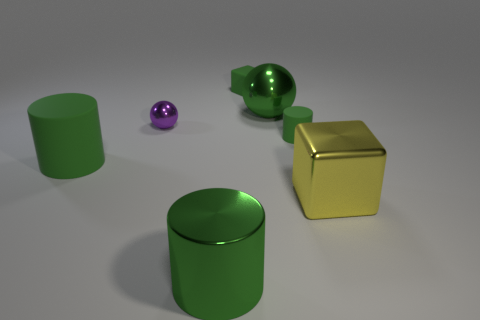Subtract all green cylinders. How many were subtracted if there are1green cylinders left? 2 Subtract all green rubber cylinders. How many cylinders are left? 1 Add 3 tiny green matte cylinders. How many objects exist? 10 Subtract all purple spheres. How many spheres are left? 1 Subtract all cubes. How many objects are left? 5 Subtract 1 cylinders. How many cylinders are left? 2 Subtract all tiny purple metal spheres. Subtract all large yellow shiny things. How many objects are left? 5 Add 4 tiny purple metal spheres. How many tiny purple metal spheres are left? 5 Add 2 large red matte things. How many large red matte things exist? 2 Subtract 1 green balls. How many objects are left? 6 